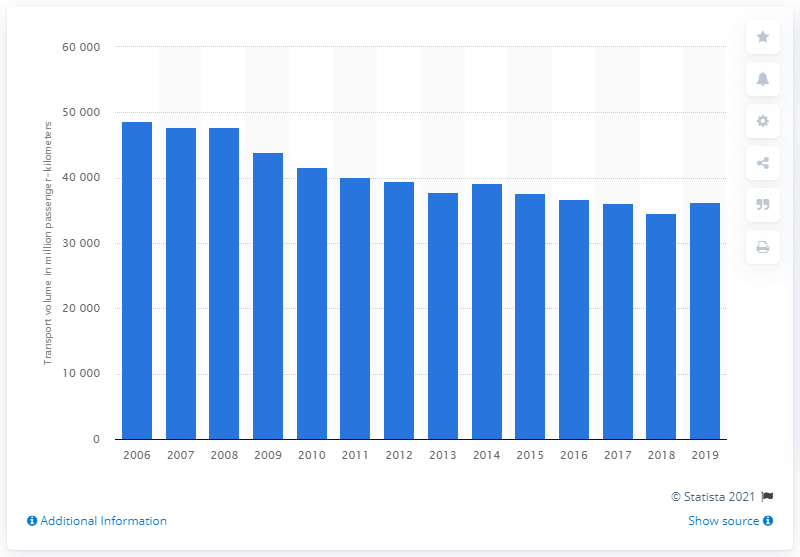Indicate a few pertinent items in this graphic. The lowest recorded volume of passenger-kilometers in 2018 was 34,544. In 2006, the highest volume of passenger-kilometers was recorded at 48,654 kilometers. 